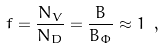Convert formula to latex. <formula><loc_0><loc_0><loc_500><loc_500>f = \frac { N _ { V } } { N _ { D } } = \frac { B } { B _ { \Phi } } \approx 1 \ ,</formula> 